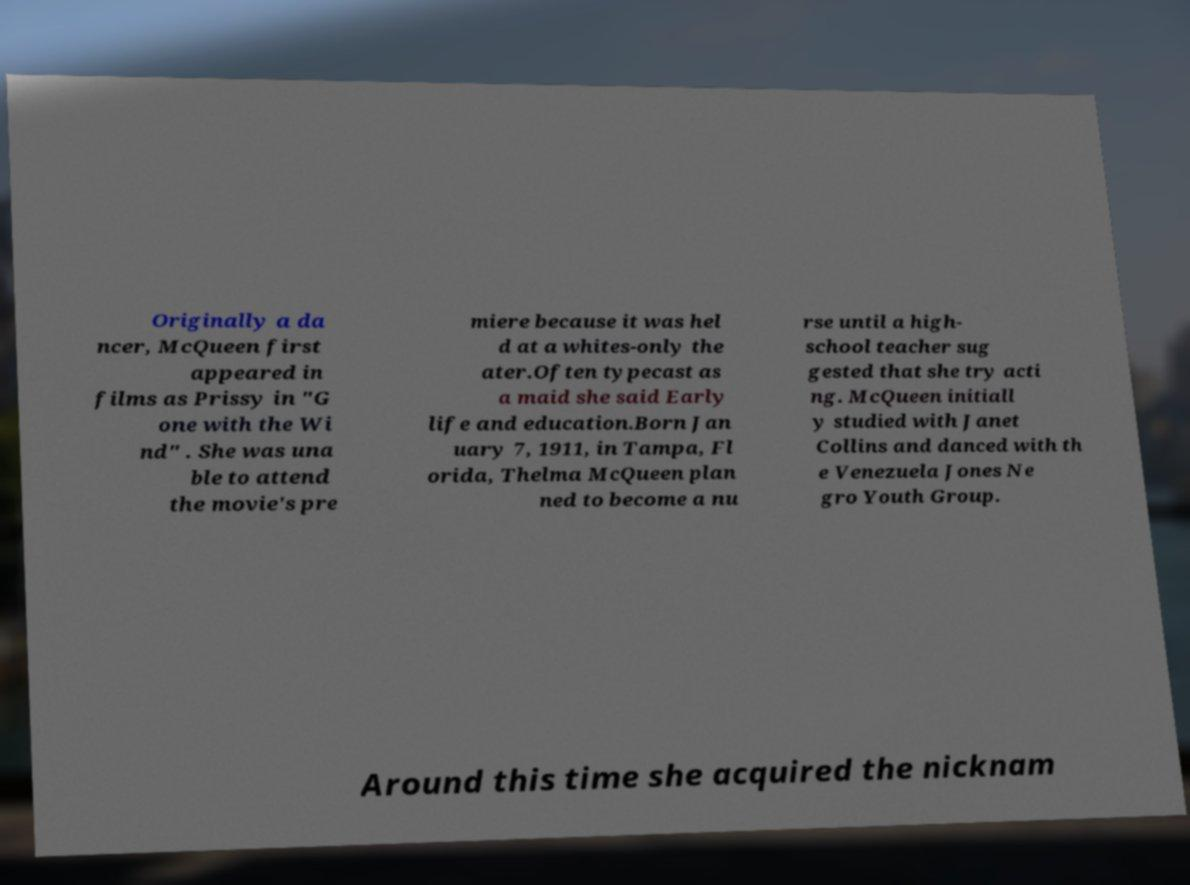Please read and relay the text visible in this image. What does it say? Originally a da ncer, McQueen first appeared in films as Prissy in "G one with the Wi nd" . She was una ble to attend the movie's pre miere because it was hel d at a whites-only the ater.Often typecast as a maid she said Early life and education.Born Jan uary 7, 1911, in Tampa, Fl orida, Thelma McQueen plan ned to become a nu rse until a high- school teacher sug gested that she try acti ng. McQueen initiall y studied with Janet Collins and danced with th e Venezuela Jones Ne gro Youth Group. Around this time she acquired the nicknam 